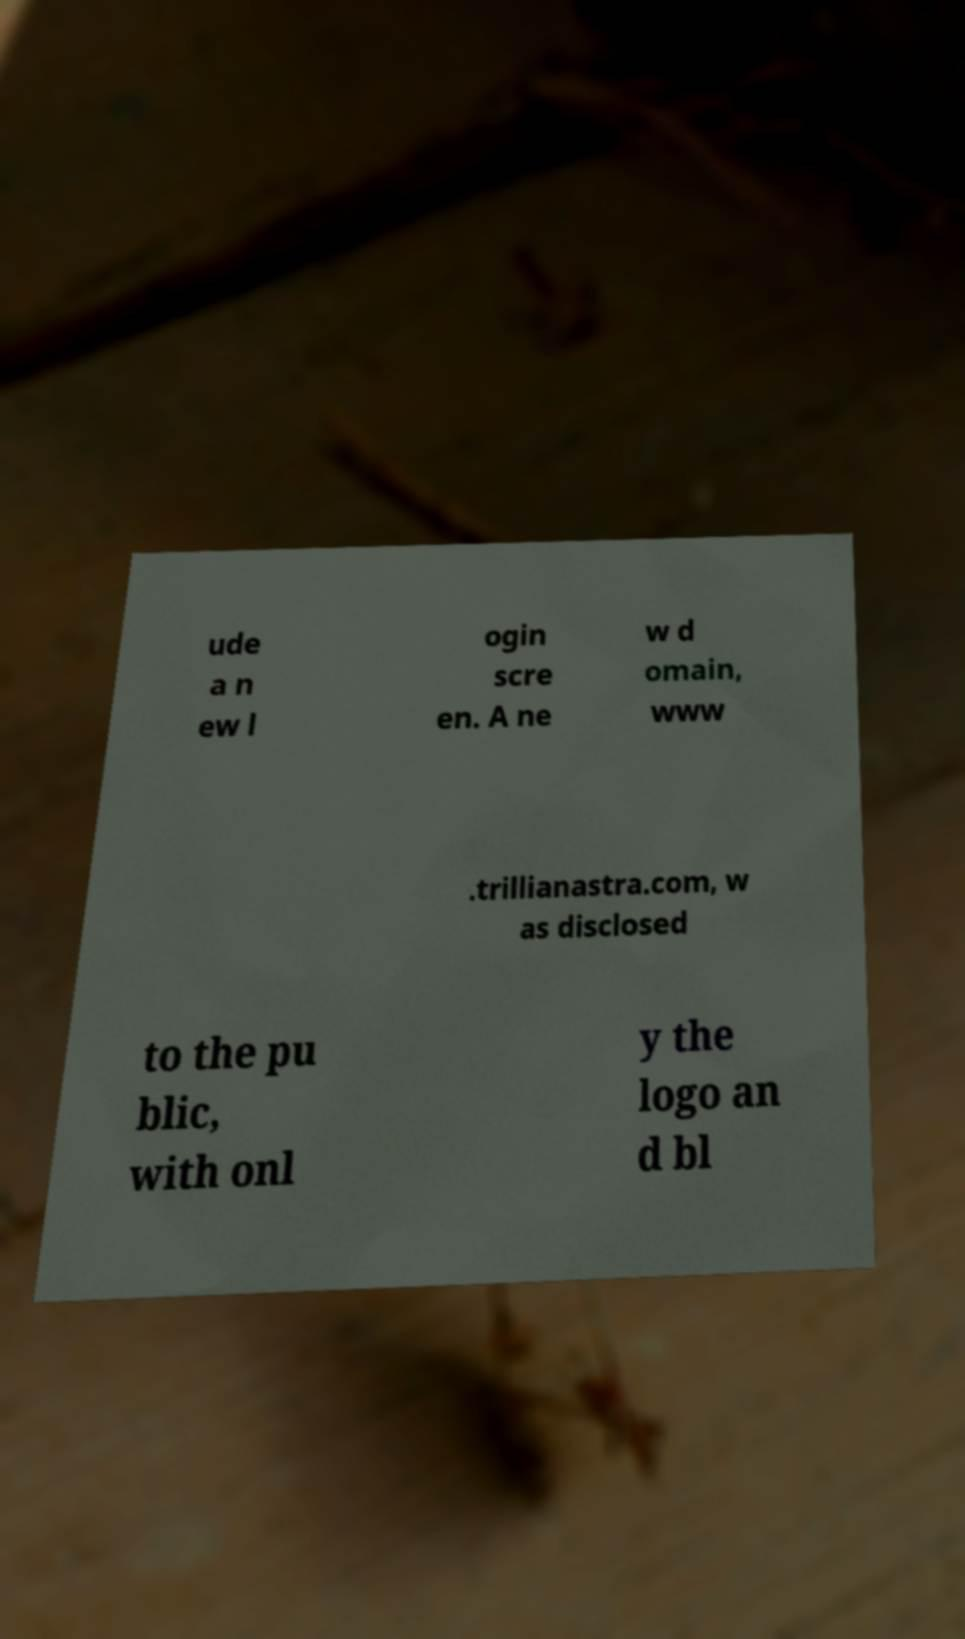I need the written content from this picture converted into text. Can you do that? ude a n ew l ogin scre en. A ne w d omain, www .trillianastra.com, w as disclosed to the pu blic, with onl y the logo an d bl 